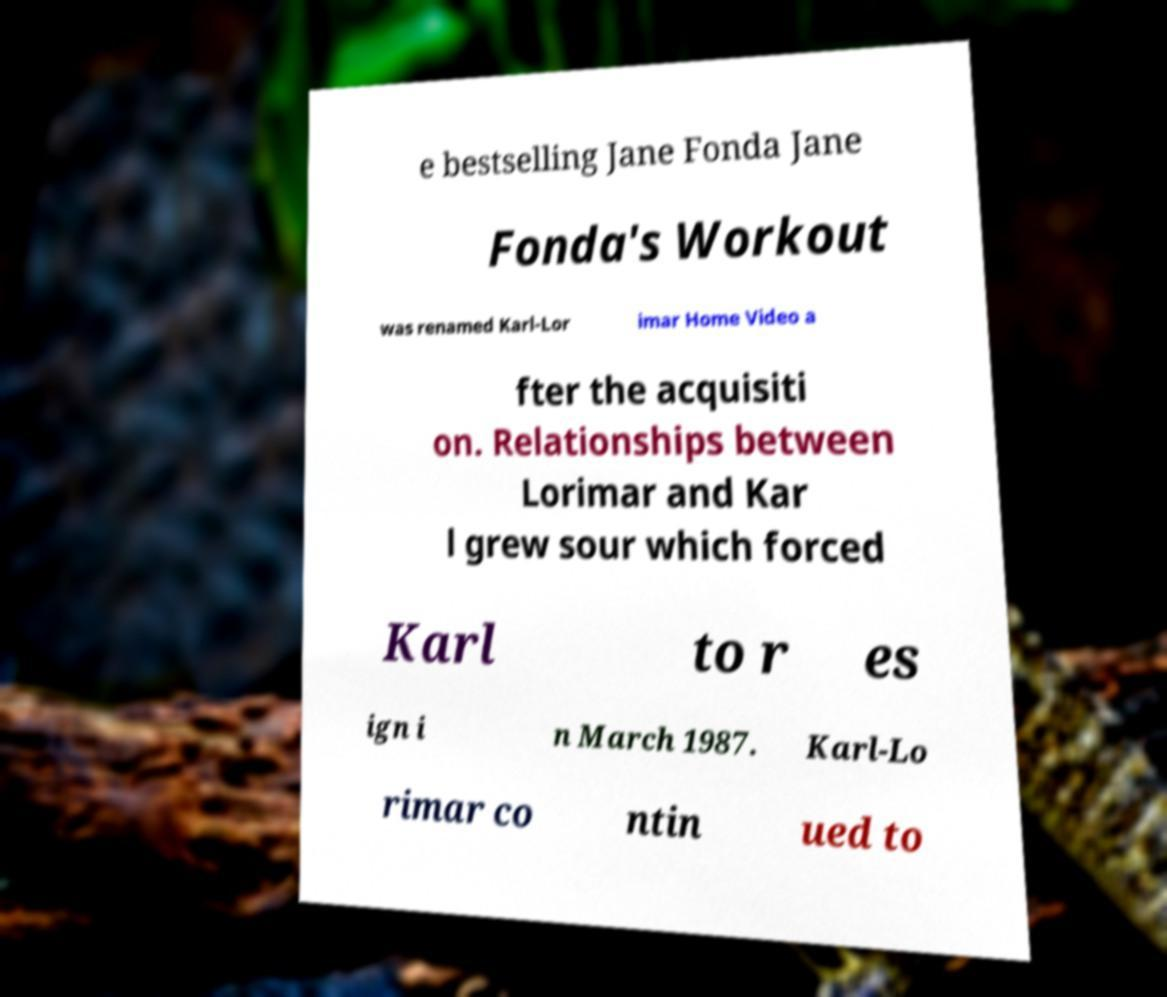There's text embedded in this image that I need extracted. Can you transcribe it verbatim? e bestselling Jane Fonda Jane Fonda's Workout was renamed Karl-Lor imar Home Video a fter the acquisiti on. Relationships between Lorimar and Kar l grew sour which forced Karl to r es ign i n March 1987. Karl-Lo rimar co ntin ued to 